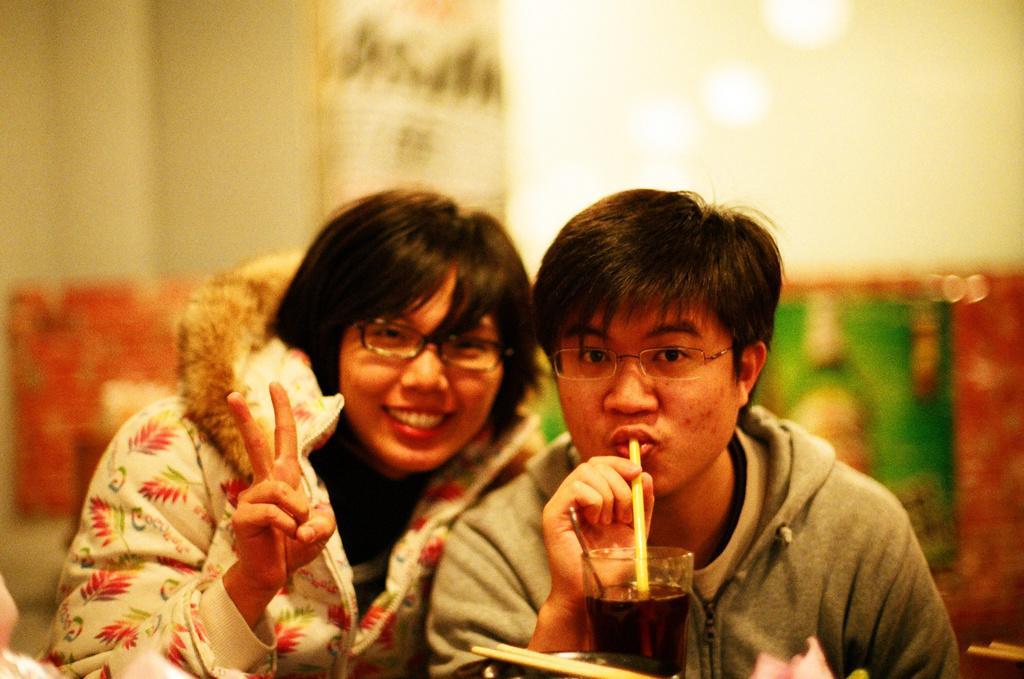In one or two sentences, can you explain what this image depicts? In this image, there are a few people. Among them, we can see a person drinking some liquid. We can see the blurred background and some objects at the bottom. 